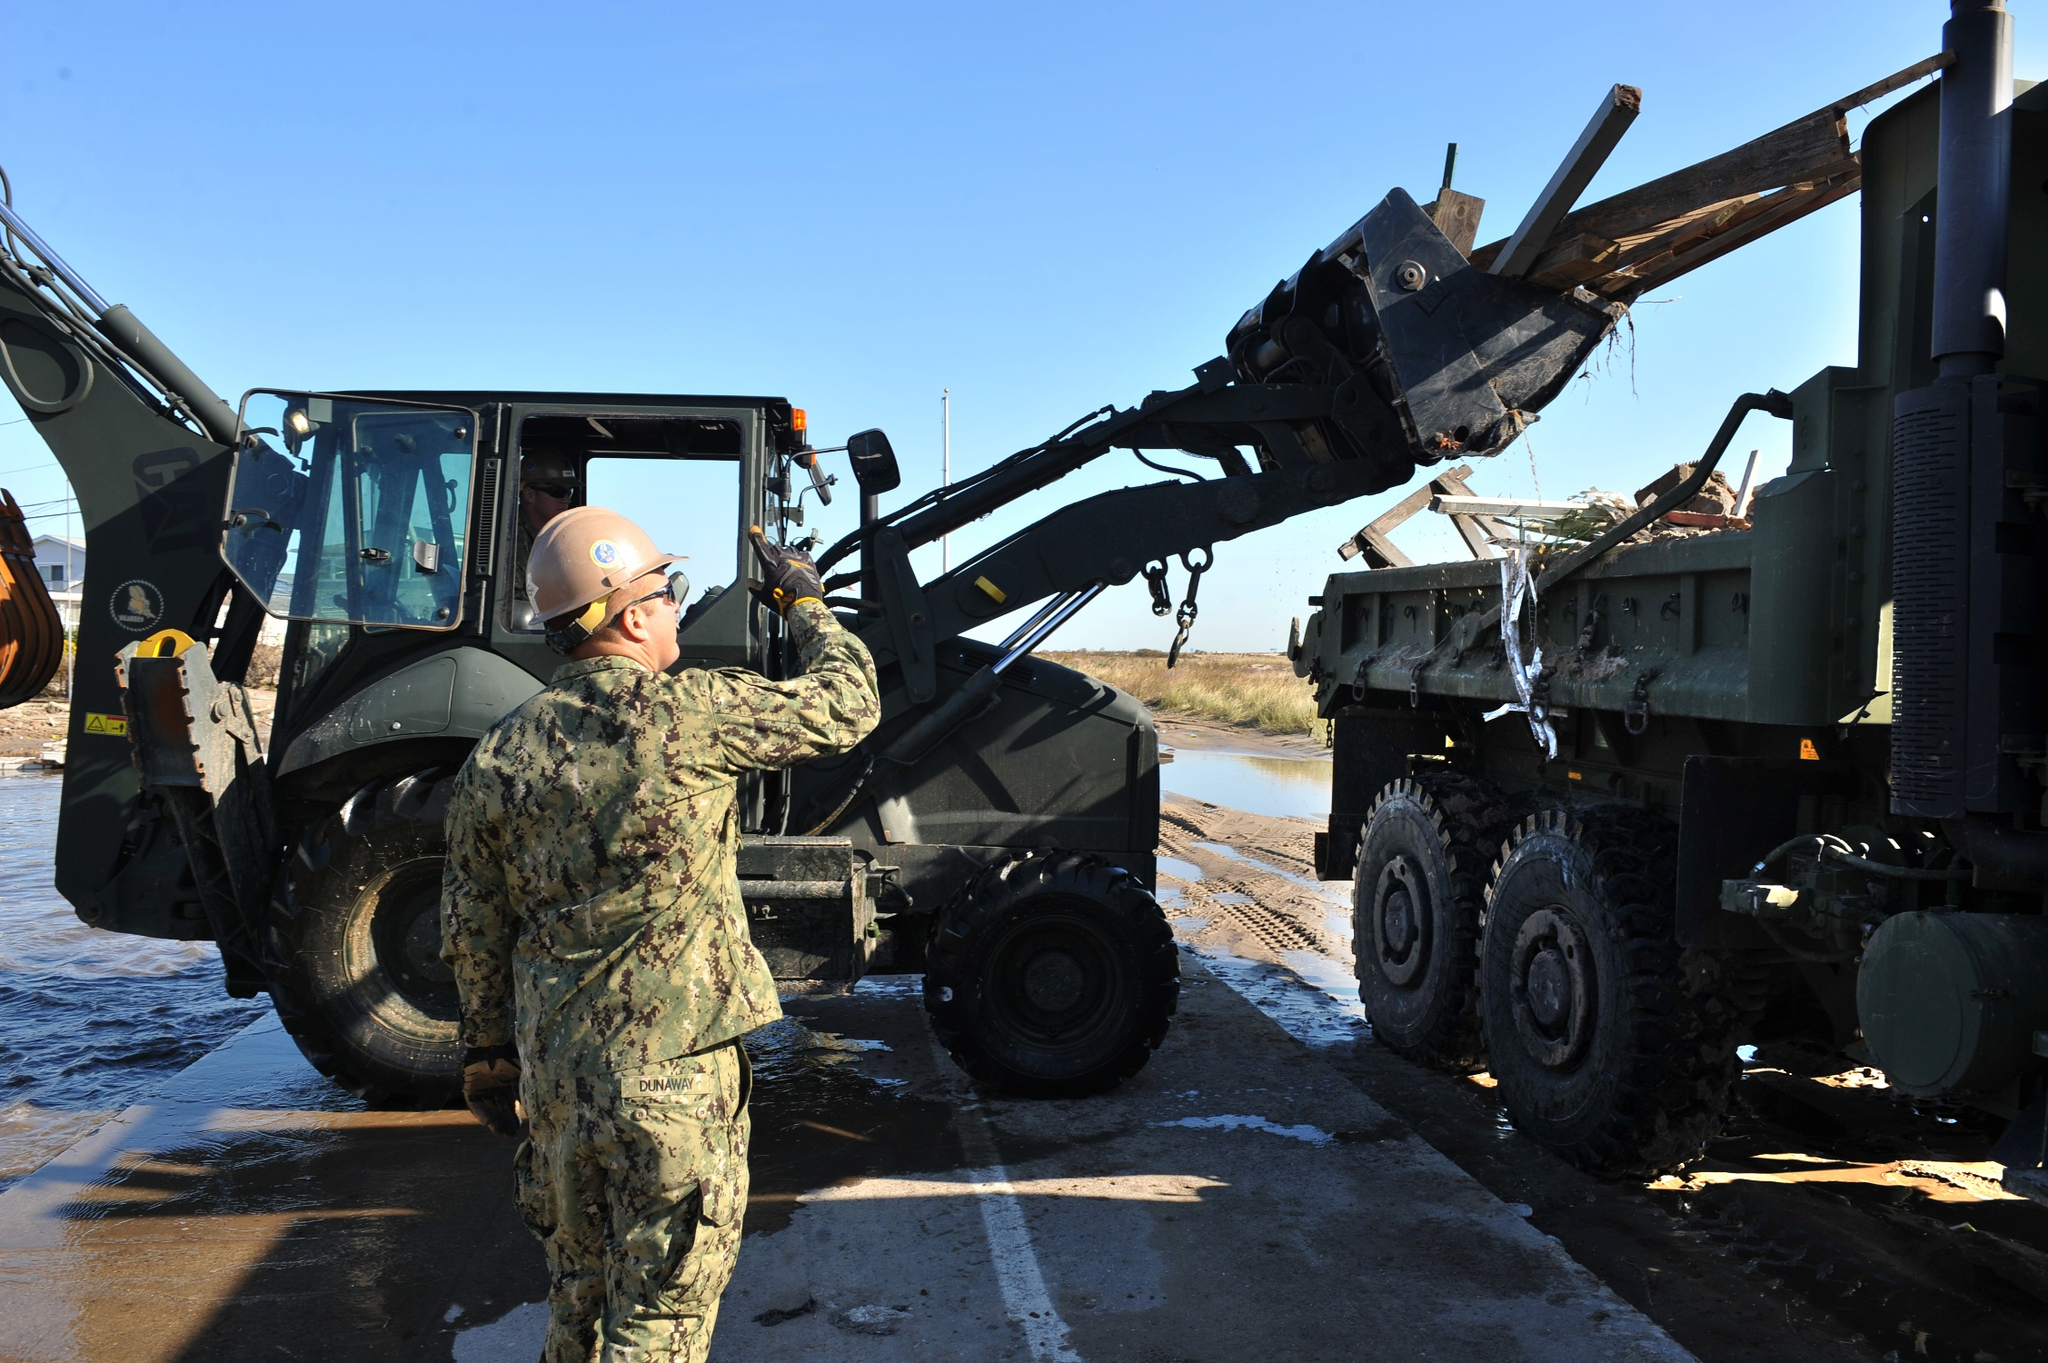What’s a casual remark that fits this scene? “Looks like a perfect day for some heavy lifting by the water, doesn't it?” 